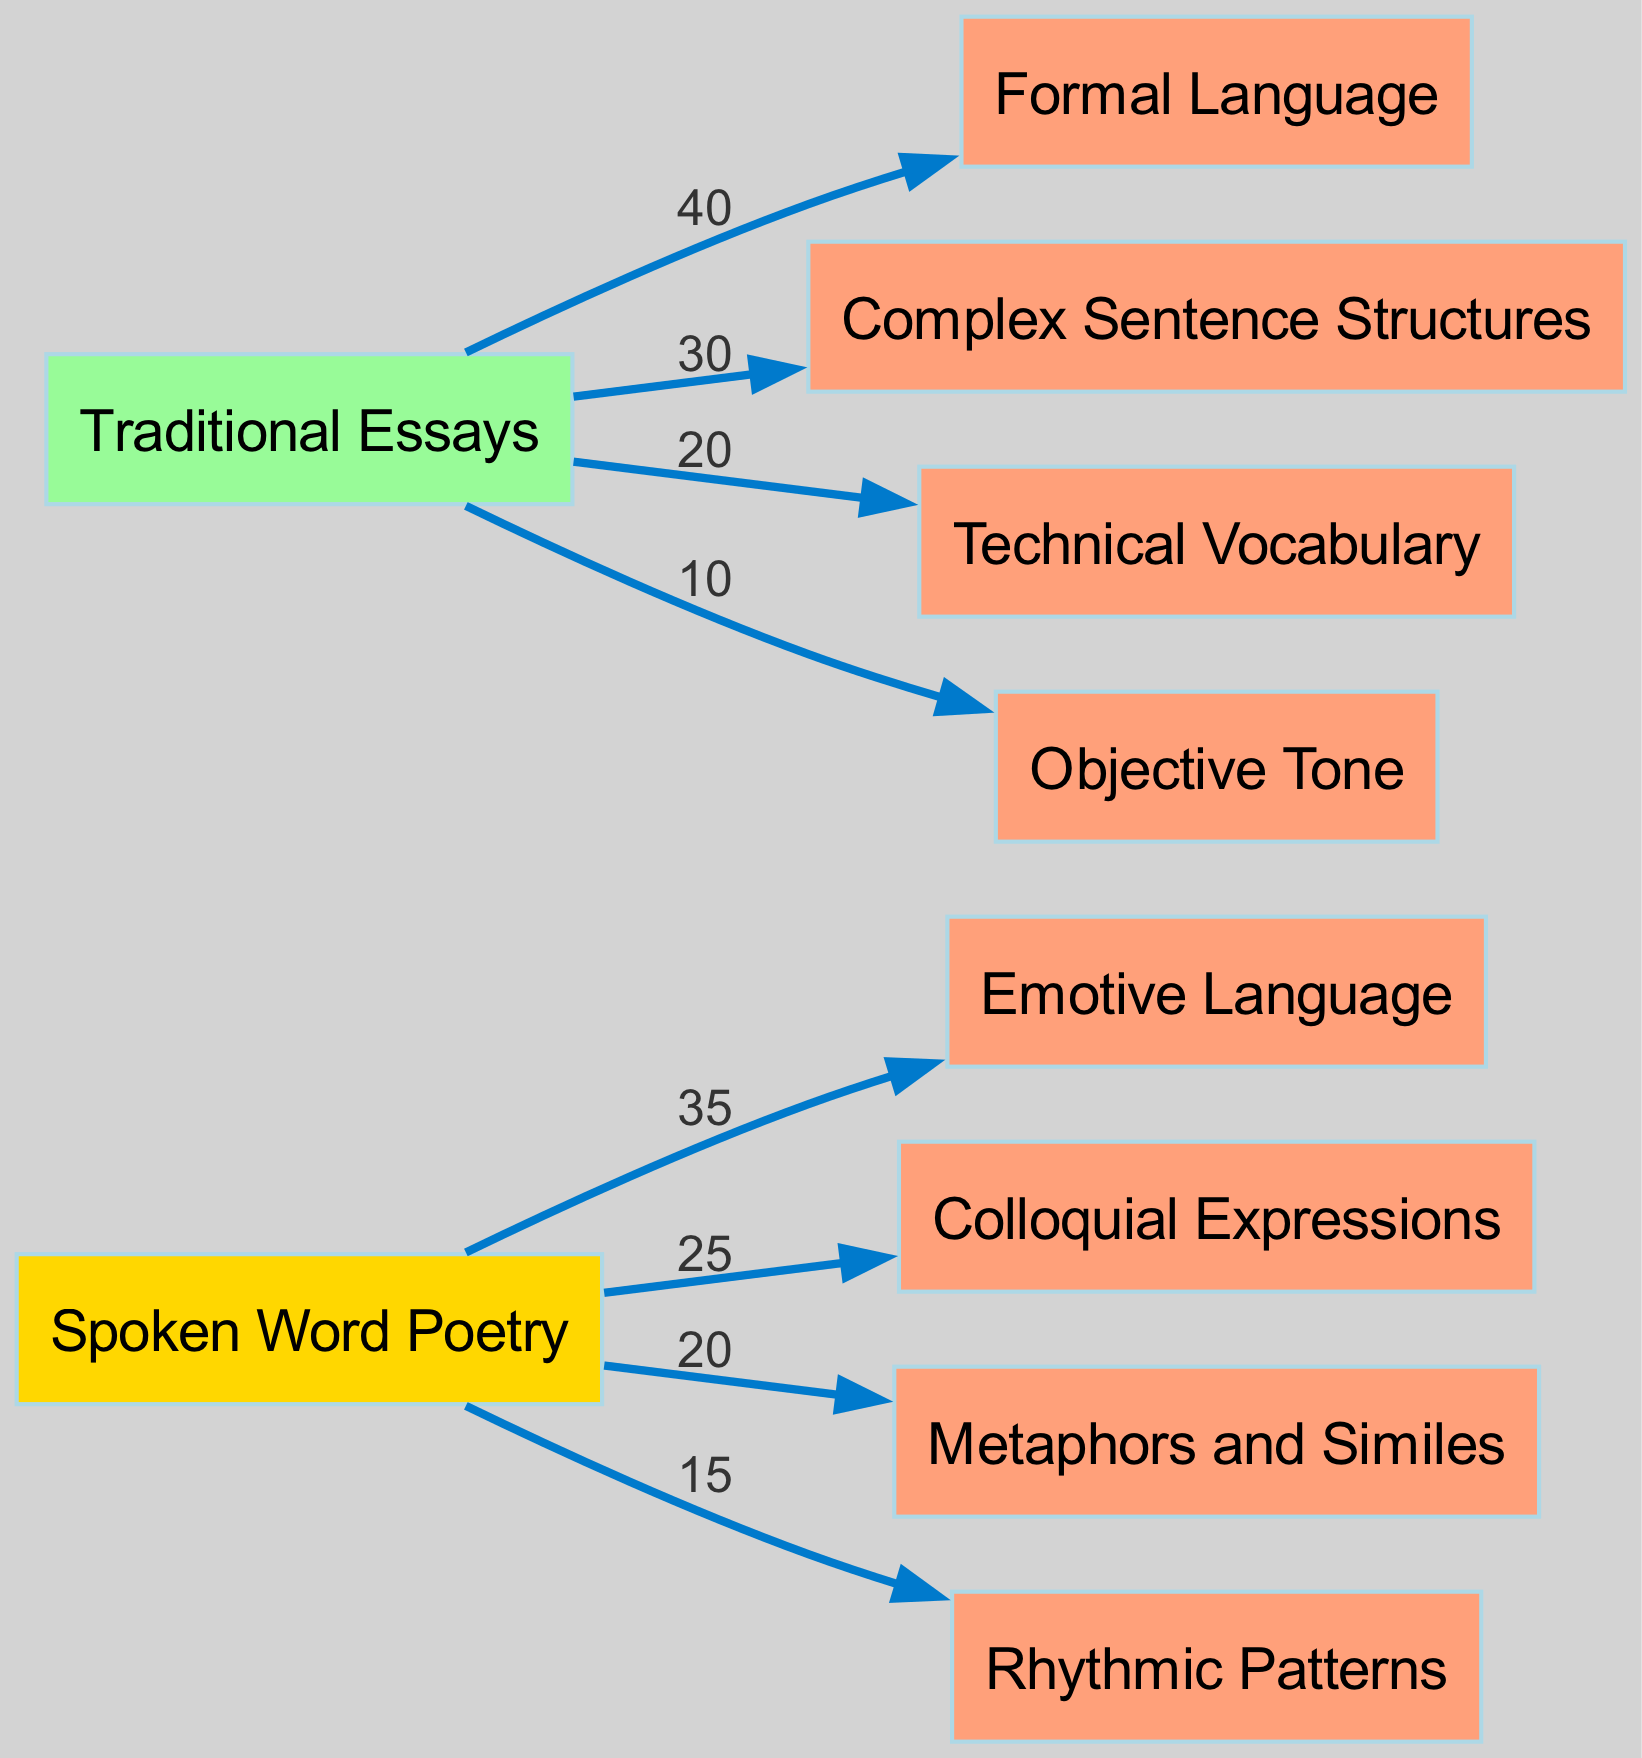What is the value of Emotive Language in Spoken Word Poetry? The diagram shows a directed edge from Spoken Word Poetry to Emotive Language with a value of 35, indicating the frequency of Emotive Language used in this form of expression.
Answer: 35 What are the two most prevalent types of language in Traditional Essays? The diagram indicates that Formal Language has the highest value at 40, followed by Complex Sentence Structures at 30. These two nodes represent the most used language types in Traditional Essays.
Answer: Formal Language and Complex Sentence Structures How many nodes are shown in the diagram? There are a total of 8 nodes in the diagram, which includes 4 for Spoken Word Poetry and 4 for Traditional Essays. Therefore, counting both language types gives a total of 8 nodes.
Answer: 8 Which form of writing uses more figurative language? Spoken Word Poetry utilizes more figurative language, indicated by the presence of Metaphors and Similes with a value of 20. In contrast, Traditional Essays do not include such language types.
Answer: Spoken Word Poetry What is the total value of language usage in Traditional Essays? To find the total, we sum the values for all language types in Traditional Essays: 40 (Formal Language) + 30 (Complex Sentence Structures) + 20 (Technical Vocabulary) + 10 (Objective Tone) = 100. Thus, the total value of language usage in Traditional Essays is 100.
Answer: 100 What percentage of vocabulary usage in Spoken Word Poetry is attributed to Colloquial Expressions? Colloquial Expressions has a value of 25 in Spoken Word Poetry, and the total value for Spoken Word Poetry is 100 (35 + 25 + 20 + 15 = 95, where we consider total contributions from all flows). The percentage is calculated as (25/95) * 100, resulting in approximately 26.32%.
Answer: 26.32% Which type of writing has a higher emphasis on an Objective Tone? The diagram shows that Traditional Essays have a higher emphasis on an Objective Tone with a value of 10, while there is no mention of such a tone in Spoken Word Poetry, indicating a contrast in tone emphasis.
Answer: Traditional Essays How does the value of Rhythmic Patterns in Spoken Word Poetry compare to the Technical Vocabulary in Traditional Essays? Rhythmic Patterns in Spoken Word Poetry has a value of 15, while Technical Vocabulary in Traditional Essays has a value of 20. Since 15 is less than 20, Rhythmic Patterns are less emphasized than Technical Vocabulary.
Answer: Less emphasized 